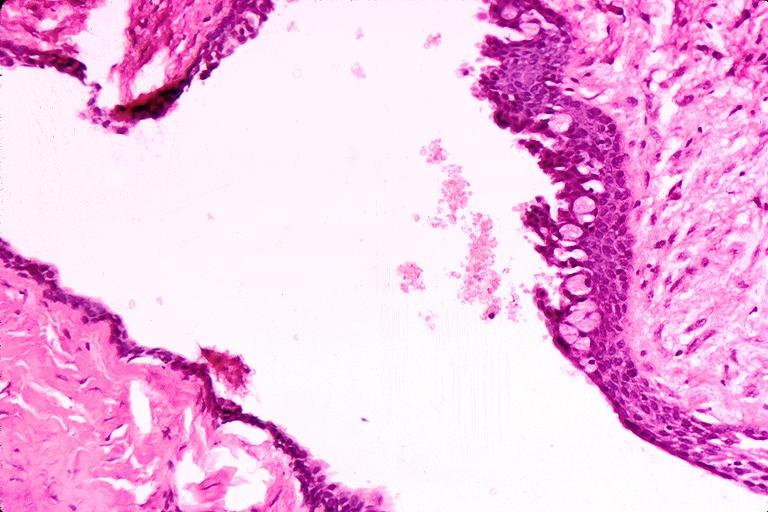where is this?
Answer the question using a single word or phrase. Oral 